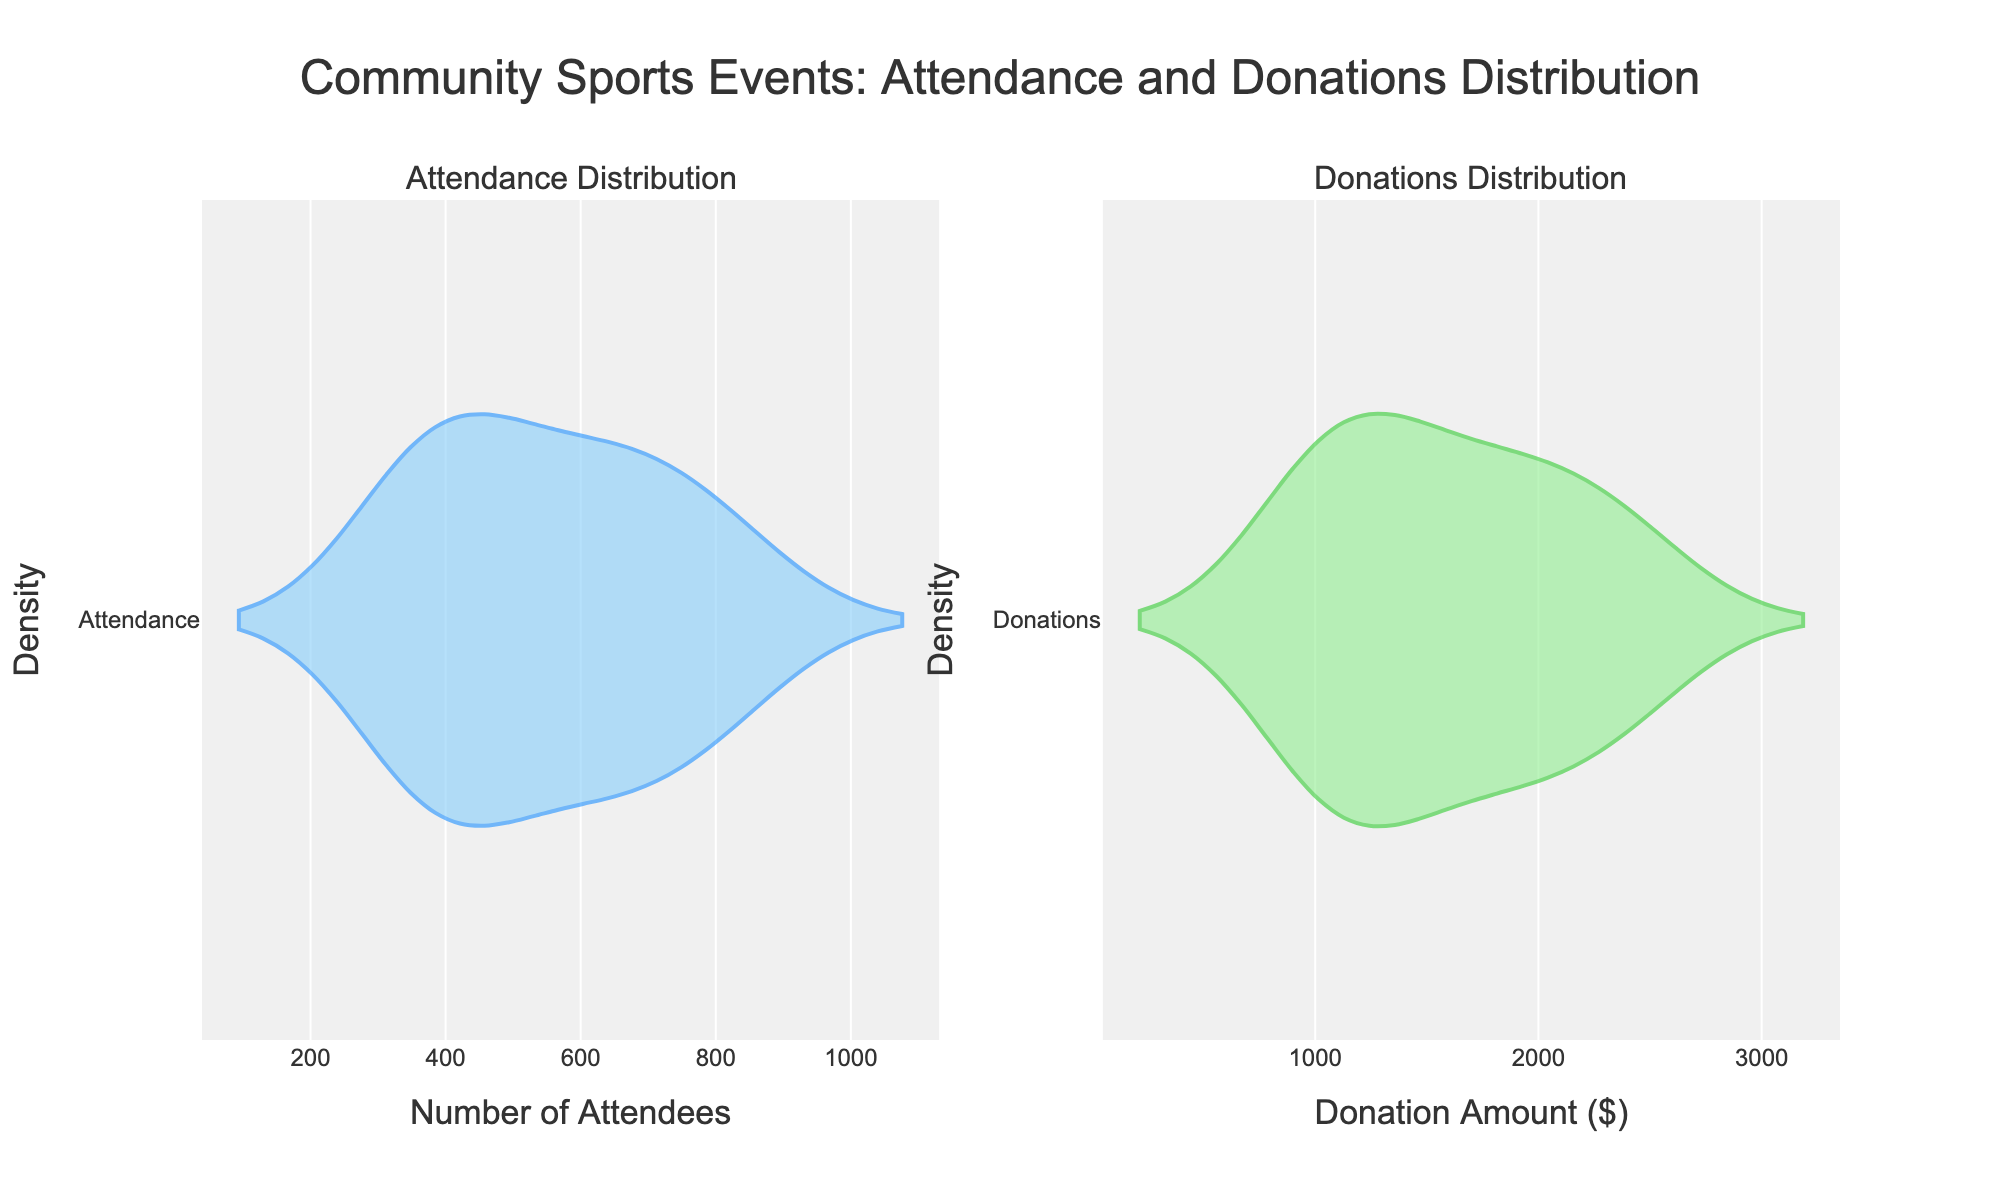What are the subplots titled? The figure contains two subplots and each of them has a title at the top. The left subplot is titled "Attendance Distribution" and the right subplot is titled "Donations Distribution".
Answer: Attendance Distribution, Donations Distribution What is the x-axis title of the left subplot? The x-axis title of the left subplot is indicated below the x-axis of the left plot. It reads "Number of Attendees".
Answer: Number of Attendees How does the color scheme differ between the two subplots? The left subplot uses a blue color scheme for the violin plot, indicated by the blue line color and fill, while the right subplot uses a green color scheme with a green line color and fill.
Answer: Left: blue, Right: green Which subplot has a higher density at the peak? By observing the height of the violin plots at their peak positions, the left subplot (Attendance) has a higher density peak compared to the right subplot (Donations).
Answer: Attendance What is the approximate range of Attendance values shown in the plot? The range of the attendance values can be seen from the x-axis of the left subplot, which roughly spans from 300 to 900 attendees.
Answer: 300 to 900 What is the median number of attendees? The median number of attendees can be estimated by looking at the widest horizontal section of the violin plot in the left subplot. This appears to be around 600 attendees.
Answer: ~600 Which subplot has a wider spread of data? The spread of data can be inferred from the width of the violin plots. The left subplot (Attendance) shows a wider spread, indicating more variability in the attendance data.
Answer: Attendance Are donations generally higher, lower, or about the same compared to attendance values? By comparing the x-axis ranges of both subplots, donations (ranging from about 900 to 2500) are generally higher than attendance values (ranging from about 300 to 900).
Answer: Higher What is one common feature of the Donation values based on the plot? The donation values show a smaller spread and are more concentrated around the center, indicating lesser variability in donation amounts compared to attendance.
Answer: Smaller Spread 